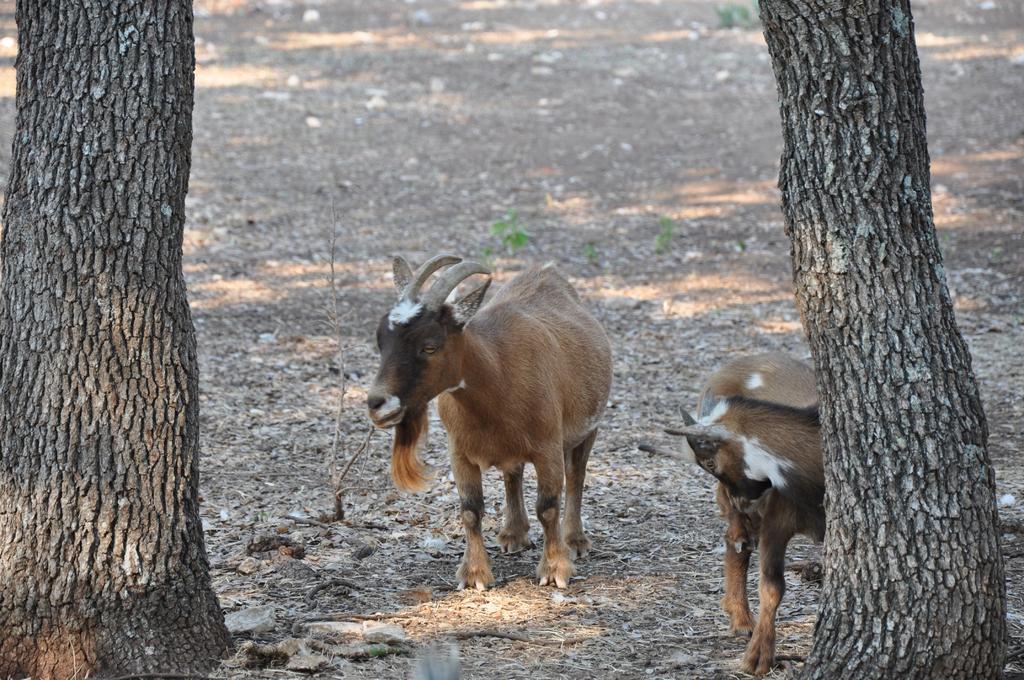Could you give a brief overview of what you see in this image? In this image we can see two animals, two trees and some plants on the surface. 